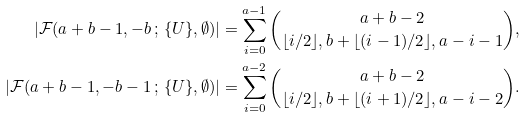<formula> <loc_0><loc_0><loc_500><loc_500>| \mathcal { F } ( a + b - 1 , - b \, ; \, \{ U \} , \emptyset ) | & = \sum _ { i = 0 } ^ { a - 1 } \binom { a + b - 2 } { \lfloor i / 2 \rfloor , b + \lfloor ( i - 1 ) / 2 \rfloor , a - i - 1 } , \\ | \mathcal { F } ( a + b - 1 , - b - 1 \, ; \, \{ U \} , \emptyset ) | & = \sum _ { i = 0 } ^ { a - 2 } \binom { a + b - 2 } { \lfloor i / 2 \rfloor , b + \lfloor ( i + 1 ) / 2 \rfloor , a - i - 2 } .</formula> 